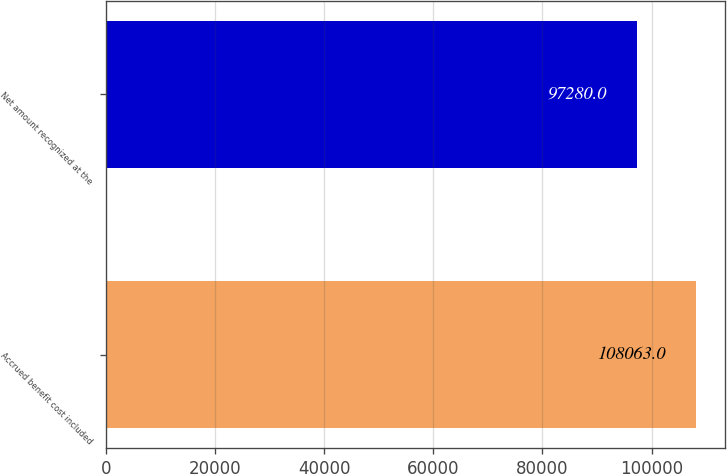Convert chart to OTSL. <chart><loc_0><loc_0><loc_500><loc_500><bar_chart><fcel>Accrued benefit cost included<fcel>Net amount recognized at the<nl><fcel>108063<fcel>97280<nl></chart> 